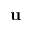Convert formula to latex. <formula><loc_0><loc_0><loc_500><loc_500>u</formula> 